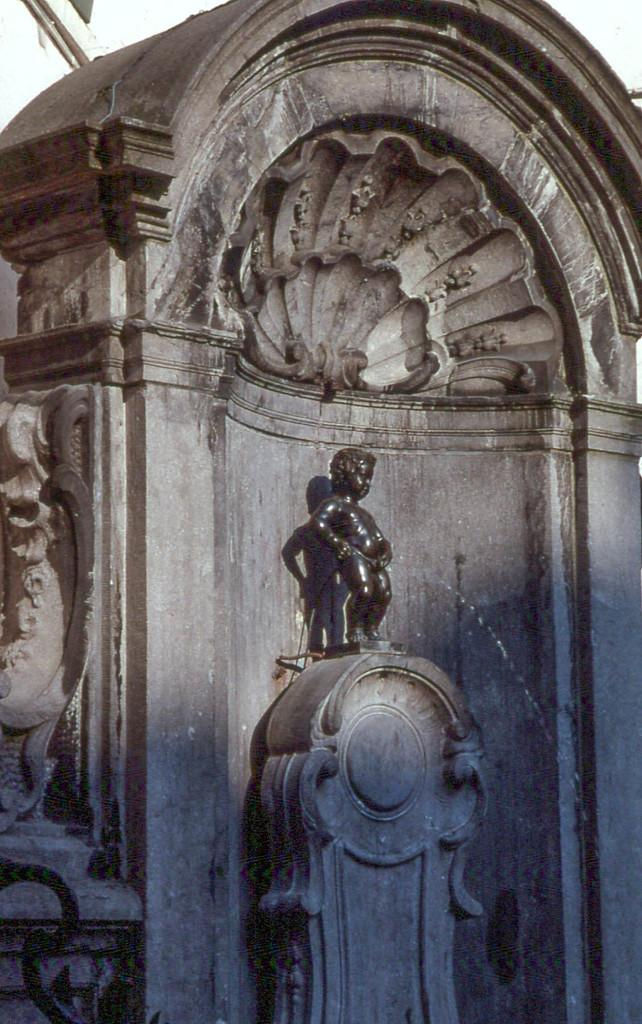What is there is a sculpture in the image, what does it contain? The sculpture contains a statue of a boy. How is the statue of the boy positioned within the sculpture? The statue of the boy is standing on a pillar. What type of teeth can be seen on the statue of the boy in the image? There are no teeth visible on the statue of the boy in the image, as statues typically do not have teeth. 